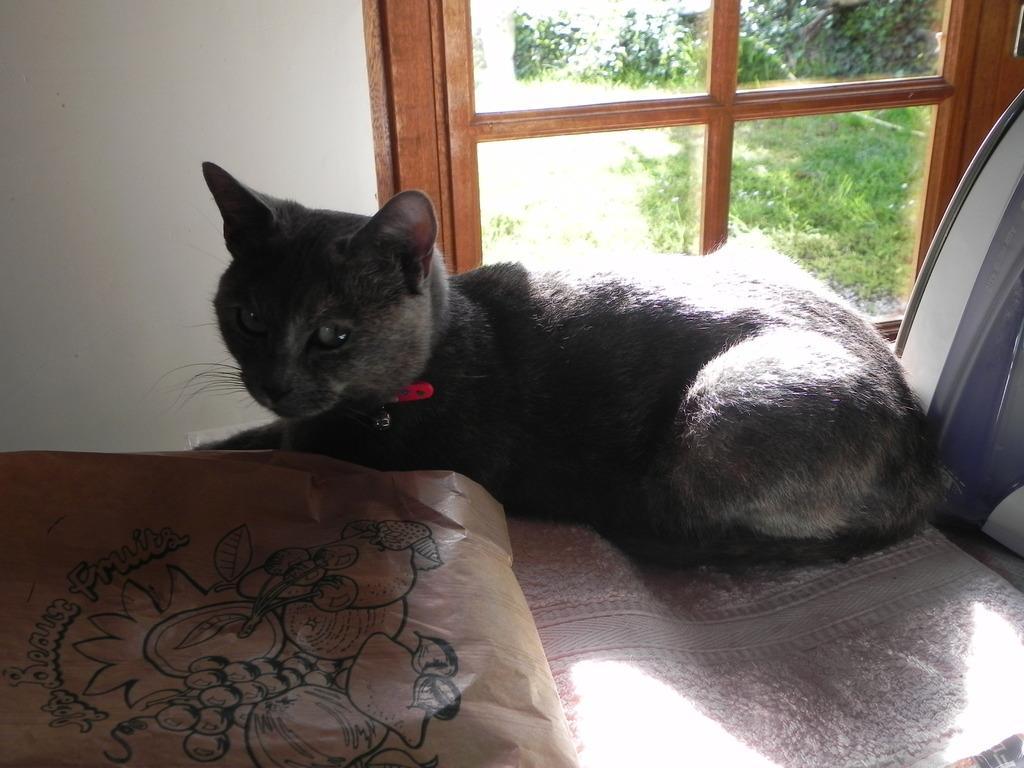Could you give a brief overview of what you see in this image? This picture shows a black cat and we see a paper bag and we see a window from the window we see trees and grass on the ground and we see a red color belt in the cat's neck. 